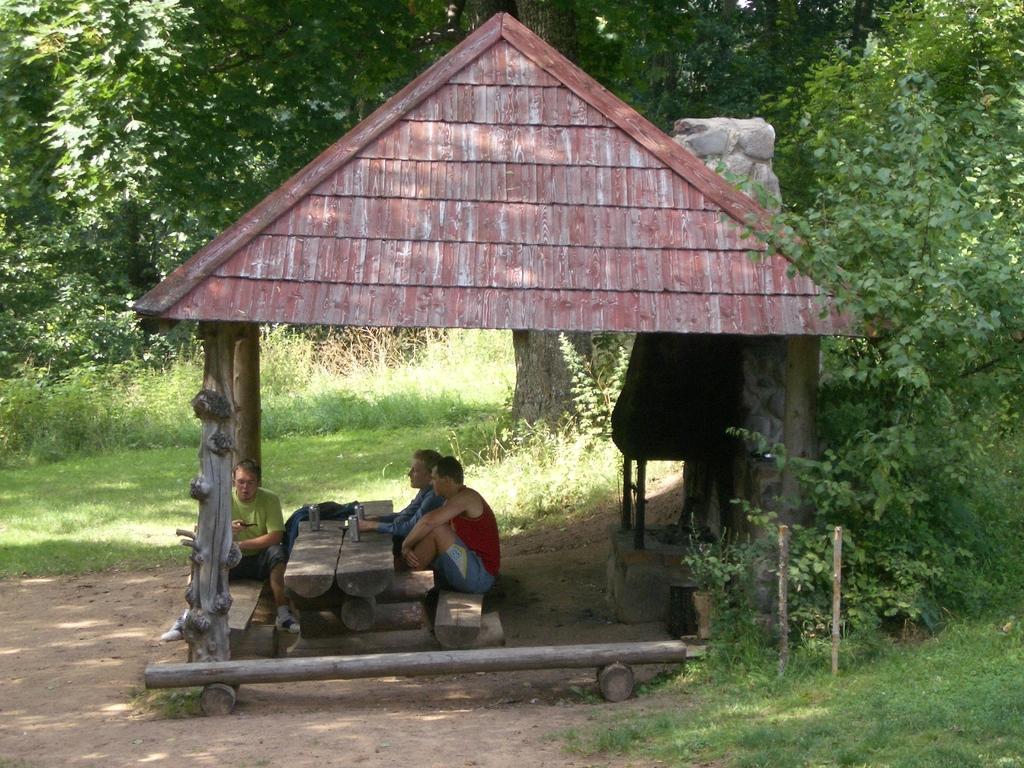Please provide a concise description of this image. This picture is clicked outside. In the foreground we can see the green grass and poles. In the center there are three persons sitting on the benches under a tent and there is a table on the top of which some items are placed. In the background we can see the plants and trees. 